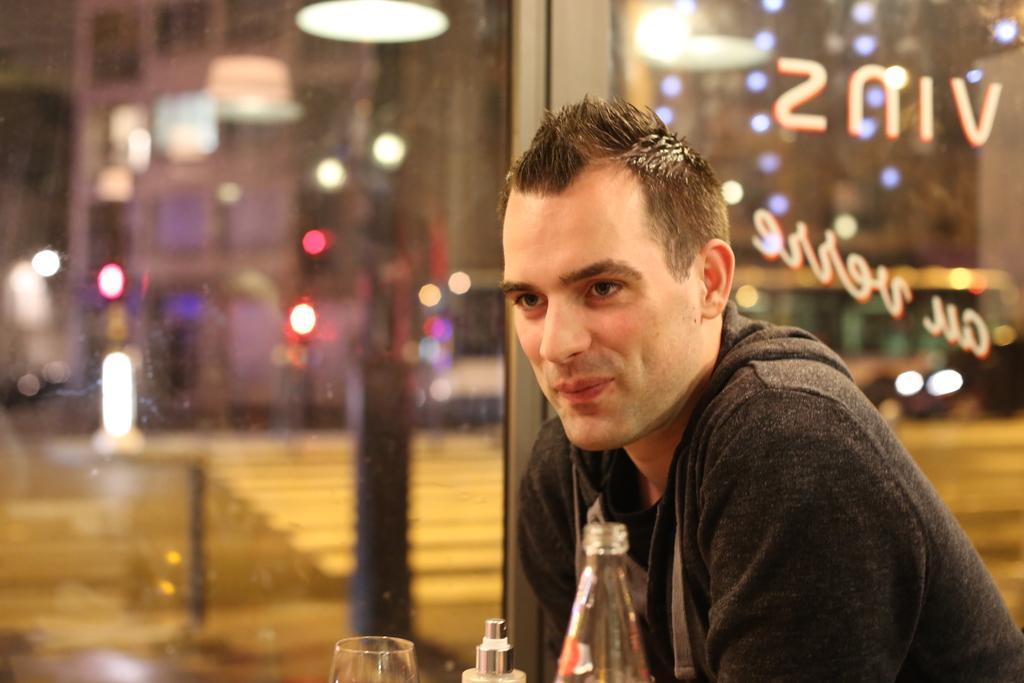In one or two sentences, can you explain what this image depicts? In this picture there is a person who is at the right side of the image and there are bottles and glass on the table which is placed in front of the man there are some doors of glasses at the center of the image behind the person, there is a lamp which is hanged above the image. 